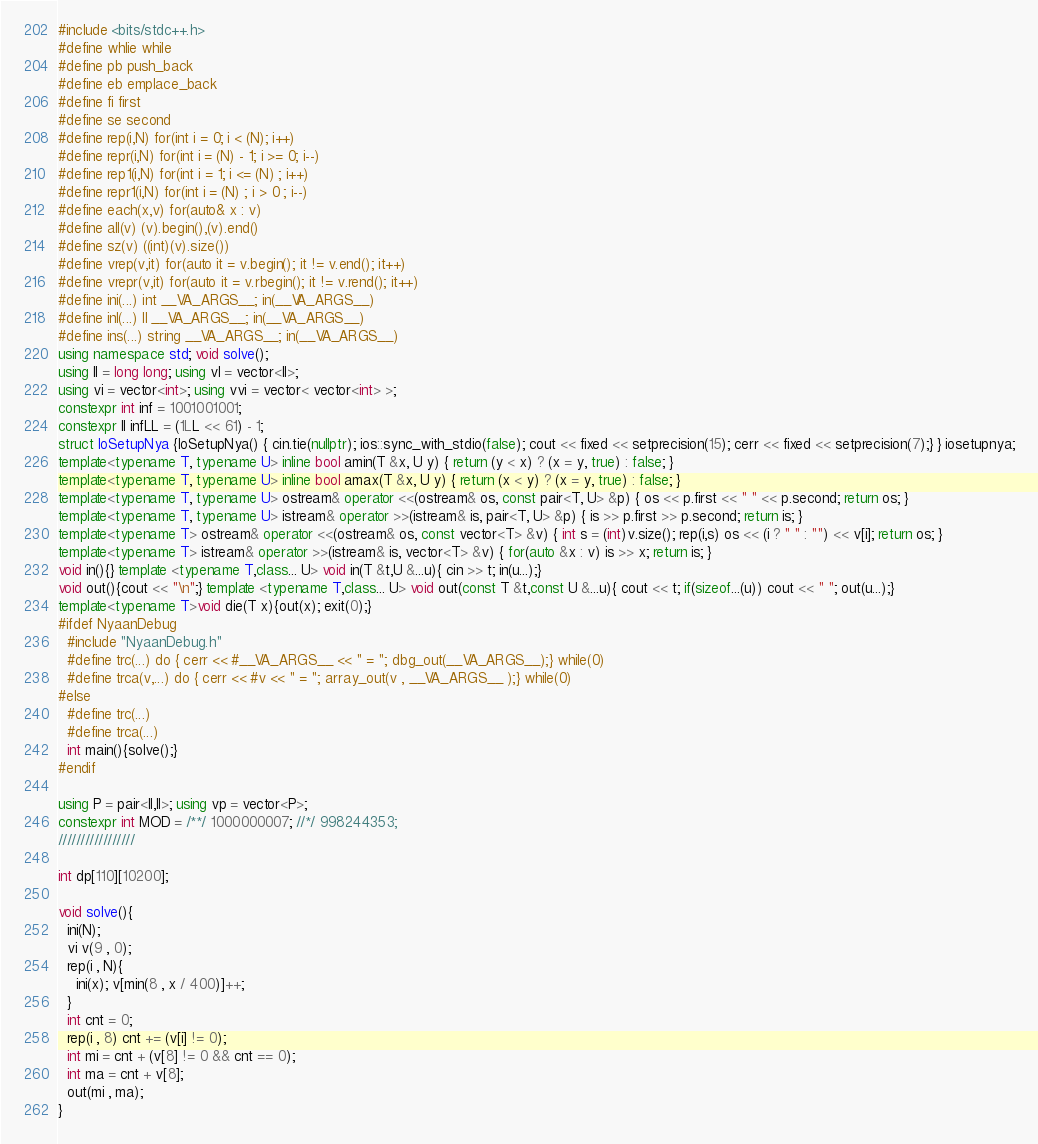<code> <loc_0><loc_0><loc_500><loc_500><_C++_>#include <bits/stdc++.h>
#define whlie while
#define pb push_back
#define eb emplace_back
#define fi first
#define se second
#define rep(i,N) for(int i = 0; i < (N); i++)
#define repr(i,N) for(int i = (N) - 1; i >= 0; i--)
#define rep1(i,N) for(int i = 1; i <= (N) ; i++)
#define repr1(i,N) for(int i = (N) ; i > 0 ; i--)
#define each(x,v) for(auto& x : v)
#define all(v) (v).begin(),(v).end()
#define sz(v) ((int)(v).size())
#define vrep(v,it) for(auto it = v.begin(); it != v.end(); it++)
#define vrepr(v,it) for(auto it = v.rbegin(); it != v.rend(); it++)
#define ini(...) int __VA_ARGS__; in(__VA_ARGS__)
#define inl(...) ll __VA_ARGS__; in(__VA_ARGS__)
#define ins(...) string __VA_ARGS__; in(__VA_ARGS__)
using namespace std; void solve();
using ll = long long; using vl = vector<ll>;
using vi = vector<int>; using vvi = vector< vector<int> >;
constexpr int inf = 1001001001;
constexpr ll infLL = (1LL << 61) - 1;
struct IoSetupNya {IoSetupNya() { cin.tie(nullptr); ios::sync_with_stdio(false); cout << fixed << setprecision(15); cerr << fixed << setprecision(7);} } iosetupnya;
template<typename T, typename U> inline bool amin(T &x, U y) { return (y < x) ? (x = y, true) : false; }
template<typename T, typename U> inline bool amax(T &x, U y) { return (x < y) ? (x = y, true) : false; }
template<typename T, typename U> ostream& operator <<(ostream& os, const pair<T, U> &p) { os << p.first << " " << p.second; return os; }
template<typename T, typename U> istream& operator >>(istream& is, pair<T, U> &p) { is >> p.first >> p.second; return is; }
template<typename T> ostream& operator <<(ostream& os, const vector<T> &v) { int s = (int)v.size(); rep(i,s) os << (i ? " " : "") << v[i]; return os; }
template<typename T> istream& operator >>(istream& is, vector<T> &v) { for(auto &x : v) is >> x; return is; }
void in(){} template <typename T,class... U> void in(T &t,U &...u){ cin >> t; in(u...);}
void out(){cout << "\n";} template <typename T,class... U> void out(const T &t,const U &...u){ cout << t; if(sizeof...(u)) cout << " "; out(u...);}
template<typename T>void die(T x){out(x); exit(0);}
#ifdef NyaanDebug
  #include "NyaanDebug.h"
  #define trc(...) do { cerr << #__VA_ARGS__ << " = "; dbg_out(__VA_ARGS__);} while(0)
  #define trca(v,...) do { cerr << #v << " = "; array_out(v , __VA_ARGS__ );} while(0)
#else
  #define trc(...)
  #define trca(...)
  int main(){solve();}
#endif
 
using P = pair<ll,ll>; using vp = vector<P>;
constexpr int MOD = /**/ 1000000007; //*/ 998244353;
/////////////////

int dp[110][10200];

void solve(){
  ini(N);
  vi v(9 , 0);
  rep(i , N){
    ini(x); v[min(8 , x / 400)]++;
  }
  int cnt = 0;
  rep(i , 8) cnt += (v[i] != 0);
  int mi = cnt + (v[8] != 0 && cnt == 0);
  int ma = cnt + v[8];
  out(mi , ma);
}

</code> 